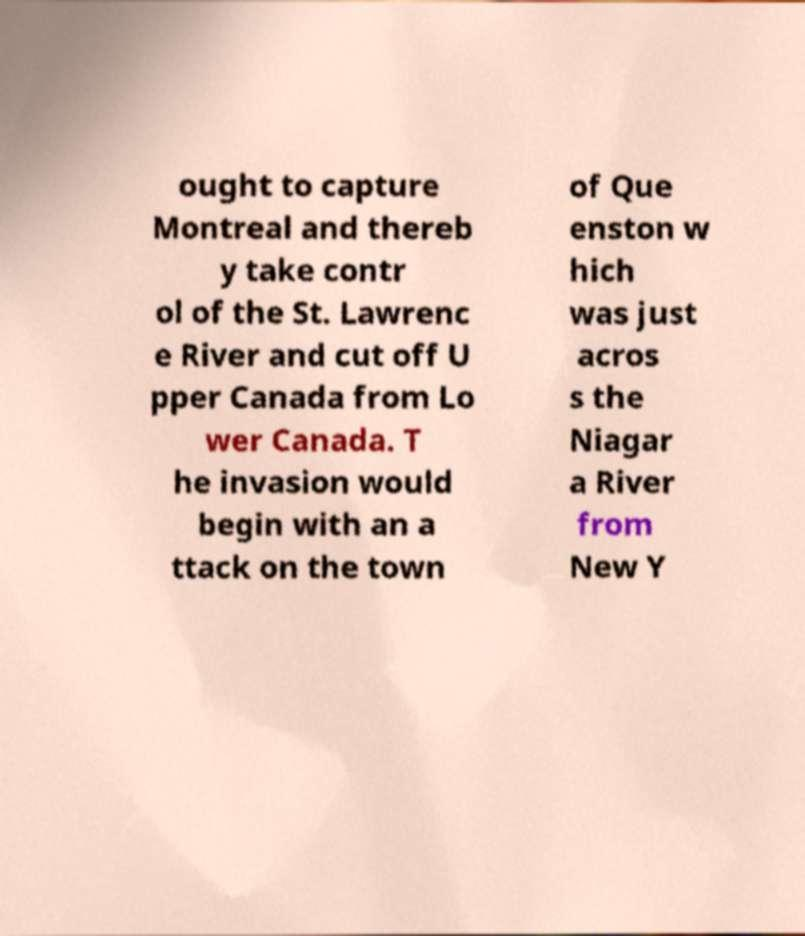Can you accurately transcribe the text from the provided image for me? ought to capture Montreal and thereb y take contr ol of the St. Lawrenc e River and cut off U pper Canada from Lo wer Canada. T he invasion would begin with an a ttack on the town of Que enston w hich was just acros s the Niagar a River from New Y 